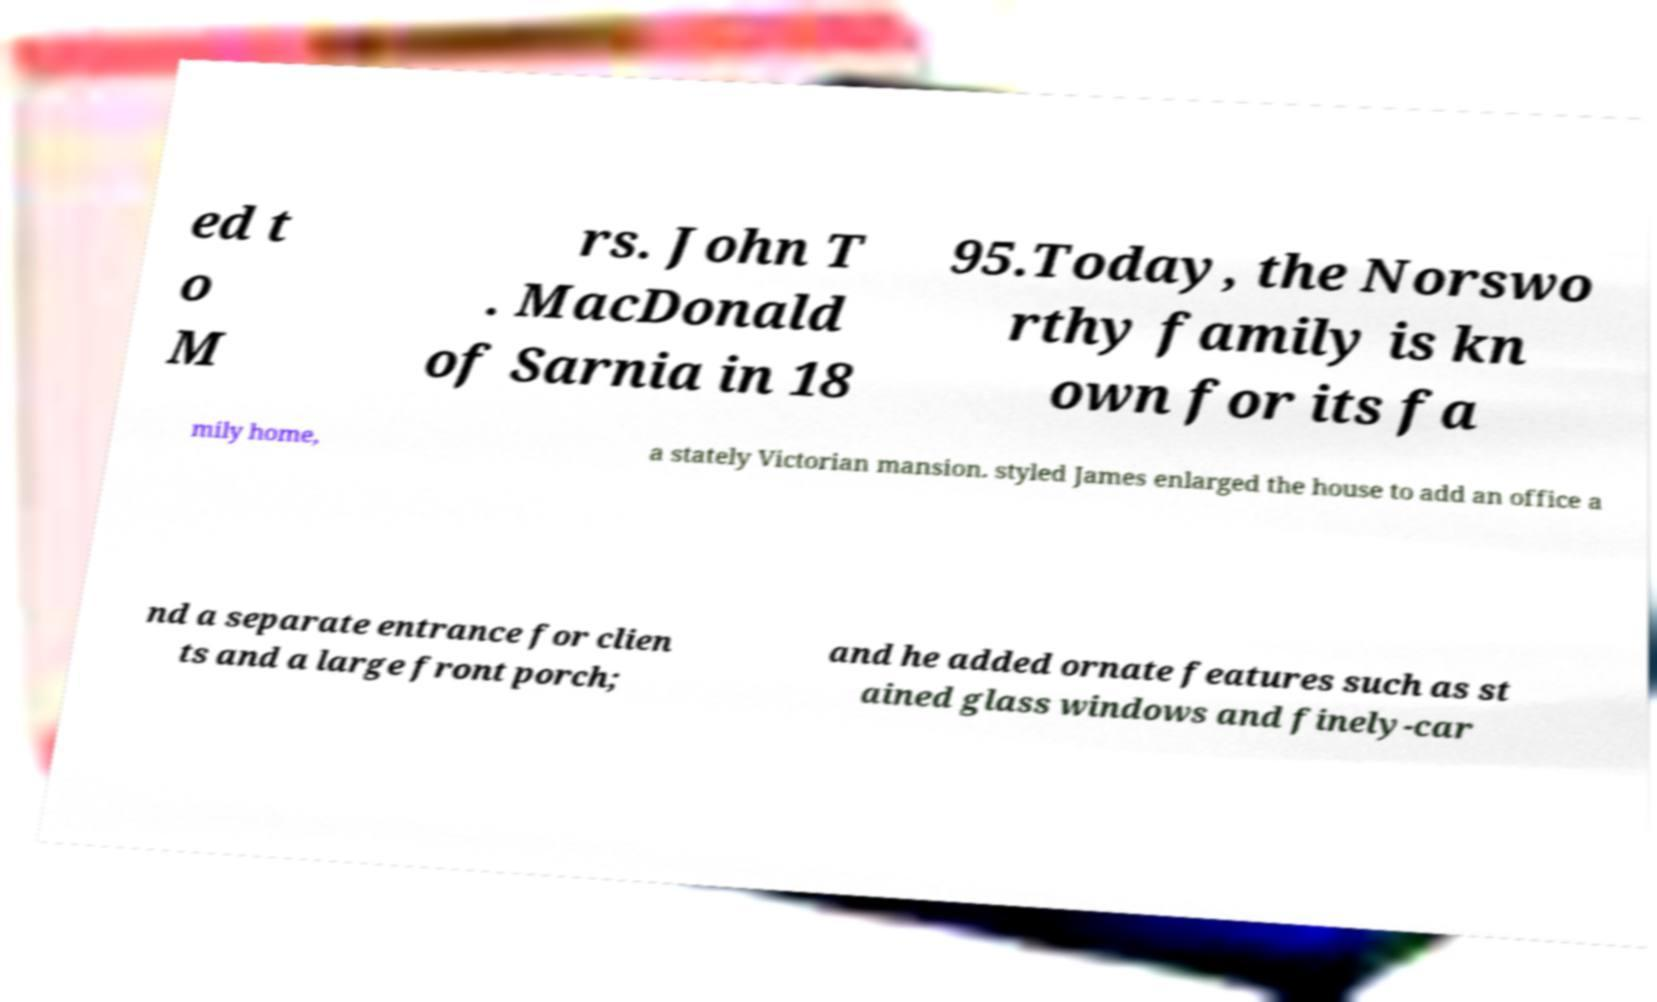Could you assist in decoding the text presented in this image and type it out clearly? ed t o M rs. John T . MacDonald of Sarnia in 18 95.Today, the Norswo rthy family is kn own for its fa mily home, a stately Victorian mansion. styled James enlarged the house to add an office a nd a separate entrance for clien ts and a large front porch; and he added ornate features such as st ained glass windows and finely-car 